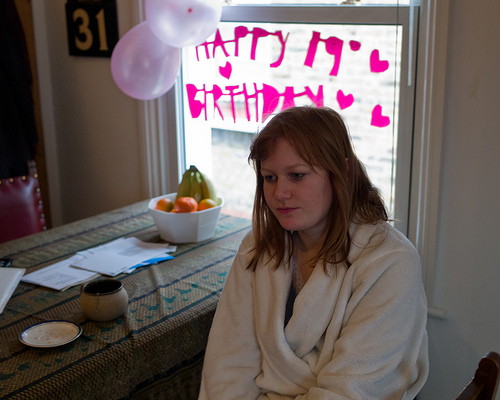<image>
Can you confirm if the window is behind the woman? Yes. From this viewpoint, the window is positioned behind the woman, with the woman partially or fully occluding the window. 